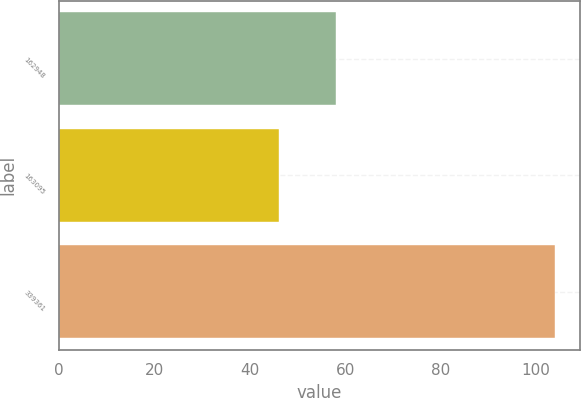Convert chart to OTSL. <chart><loc_0><loc_0><loc_500><loc_500><bar_chart><fcel>162948<fcel>163095<fcel>339361<nl><fcel>58<fcel>46<fcel>104<nl></chart> 